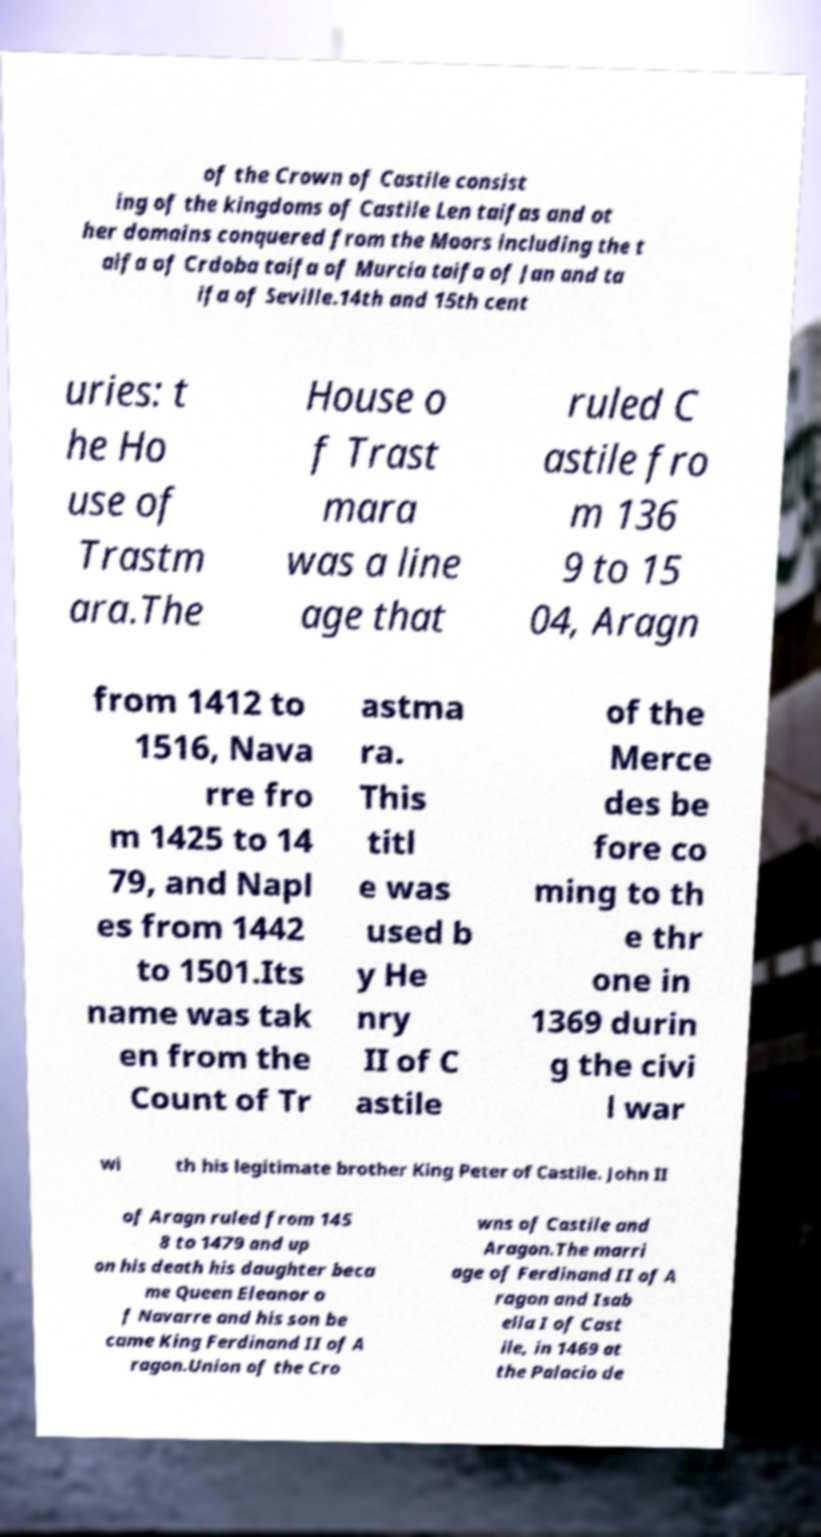What messages or text are displayed in this image? I need them in a readable, typed format. of the Crown of Castile consist ing of the kingdoms of Castile Len taifas and ot her domains conquered from the Moors including the t aifa of Crdoba taifa of Murcia taifa of Jan and ta ifa of Seville.14th and 15th cent uries: t he Ho use of Trastm ara.The House o f Trast mara was a line age that ruled C astile fro m 136 9 to 15 04, Aragn from 1412 to 1516, Nava rre fro m 1425 to 14 79, and Napl es from 1442 to 1501.Its name was tak en from the Count of Tr astma ra. This titl e was used b y He nry II of C astile of the Merce des be fore co ming to th e thr one in 1369 durin g the civi l war wi th his legitimate brother King Peter of Castile. John II of Aragn ruled from 145 8 to 1479 and up on his death his daughter beca me Queen Eleanor o f Navarre and his son be came King Ferdinand II of A ragon.Union of the Cro wns of Castile and Aragon.The marri age of Ferdinand II of A ragon and Isab ella I of Cast ile, in 1469 at the Palacio de 